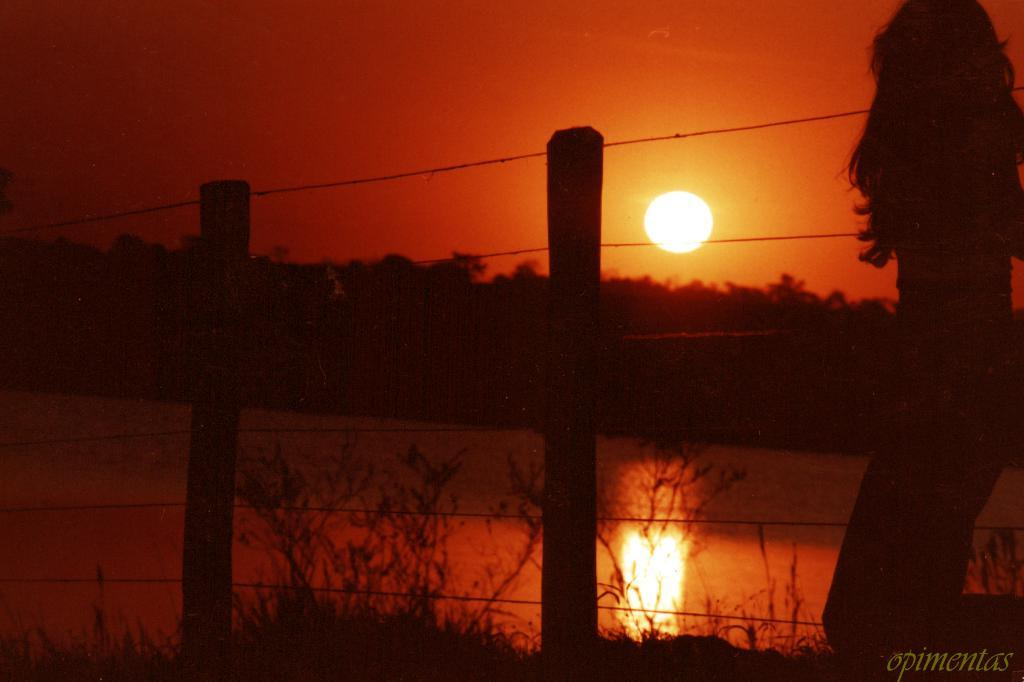Who is present on the right side of the image? There is a lady standing on the right side of the image. What is the barrier in the image? There is a fence in the image. What can be seen in the distance in the image? Water, trees, and the sky are visible in the background of the image. Can the sun be seen in the image? Yes, the sun is observable in the sky. What type of ground is present at the bottom of the image? There is grass at the bottom of the image. What type of crib is visible in the image? There is no crib present in the image. Is there any blood visible in the image? There is no blood visible in the image. Who is the grandmother in the image? There is no mention of a grandmother in the image or the provided facts. 